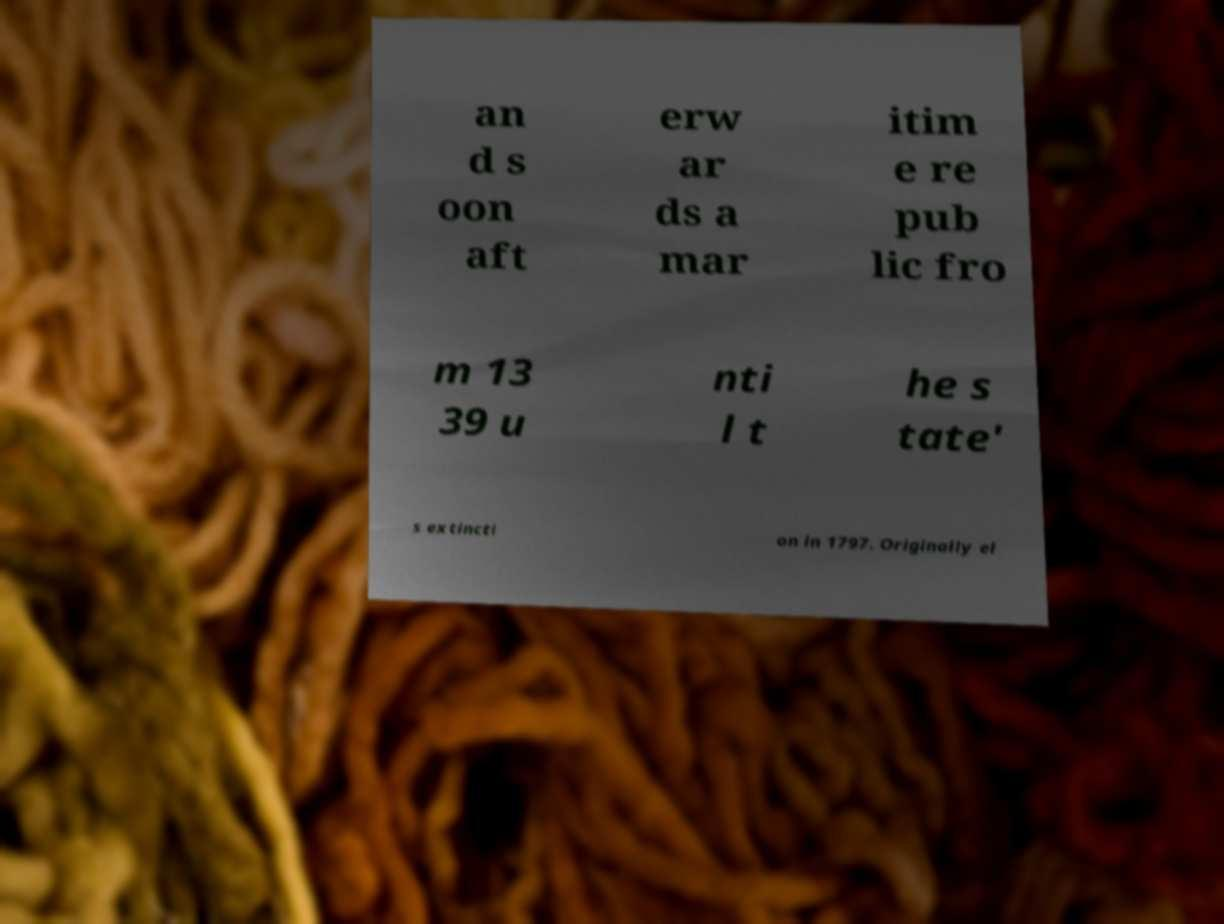Can you accurately transcribe the text from the provided image for me? an d s oon aft erw ar ds a mar itim e re pub lic fro m 13 39 u nti l t he s tate' s extincti on in 1797. Originally el 